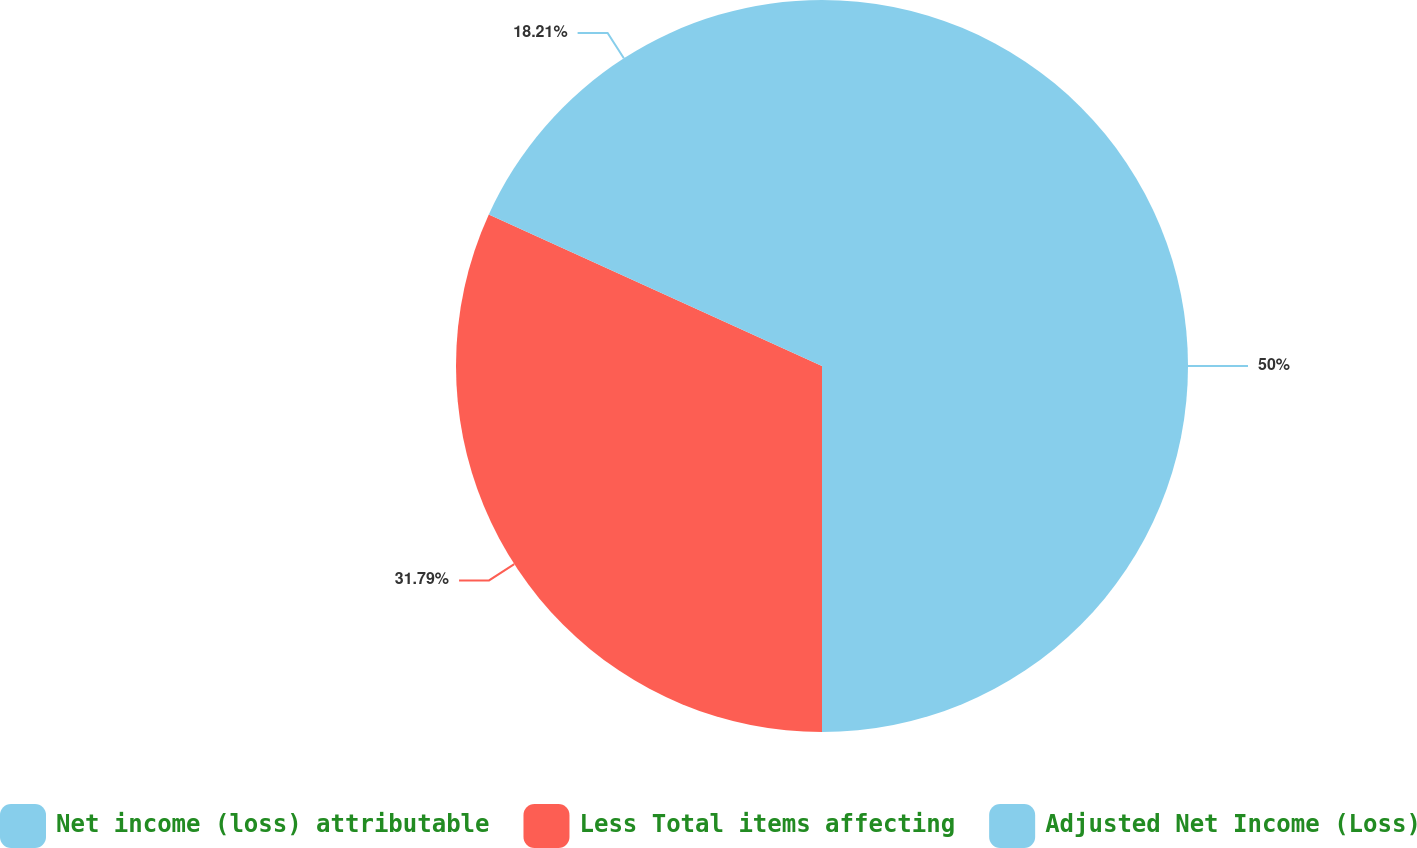Convert chart. <chart><loc_0><loc_0><loc_500><loc_500><pie_chart><fcel>Net income (loss) attributable<fcel>Less Total items affecting<fcel>Adjusted Net Income (Loss)<nl><fcel>50.0%<fcel>31.79%<fcel>18.21%<nl></chart> 